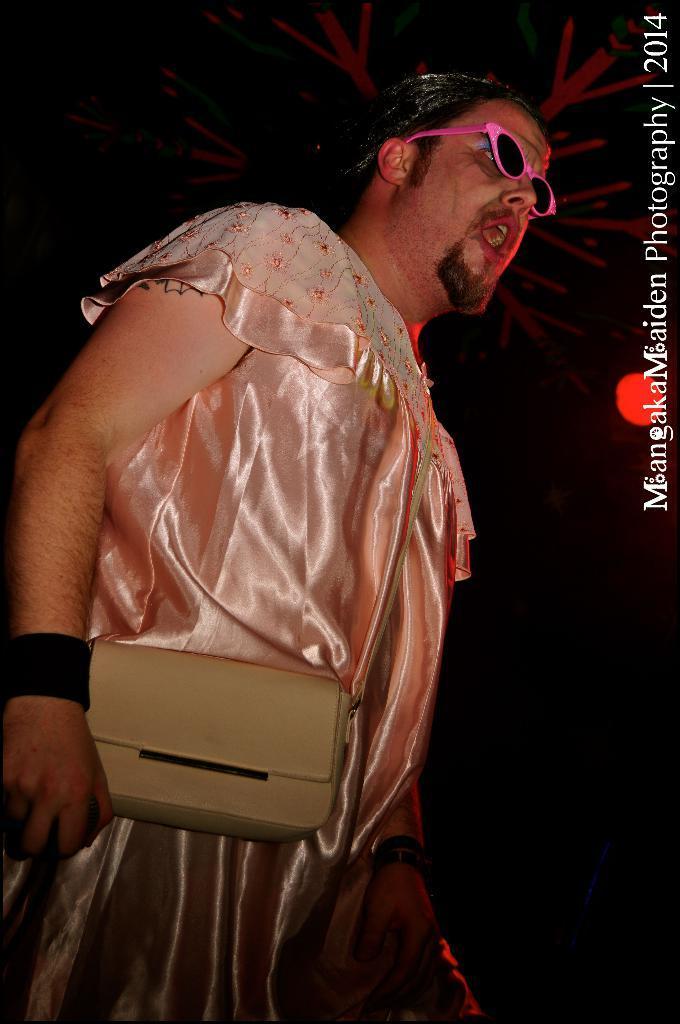Could you give a brief overview of what you see in this image? This picture shows a man standing and speaking and we see a handbag 